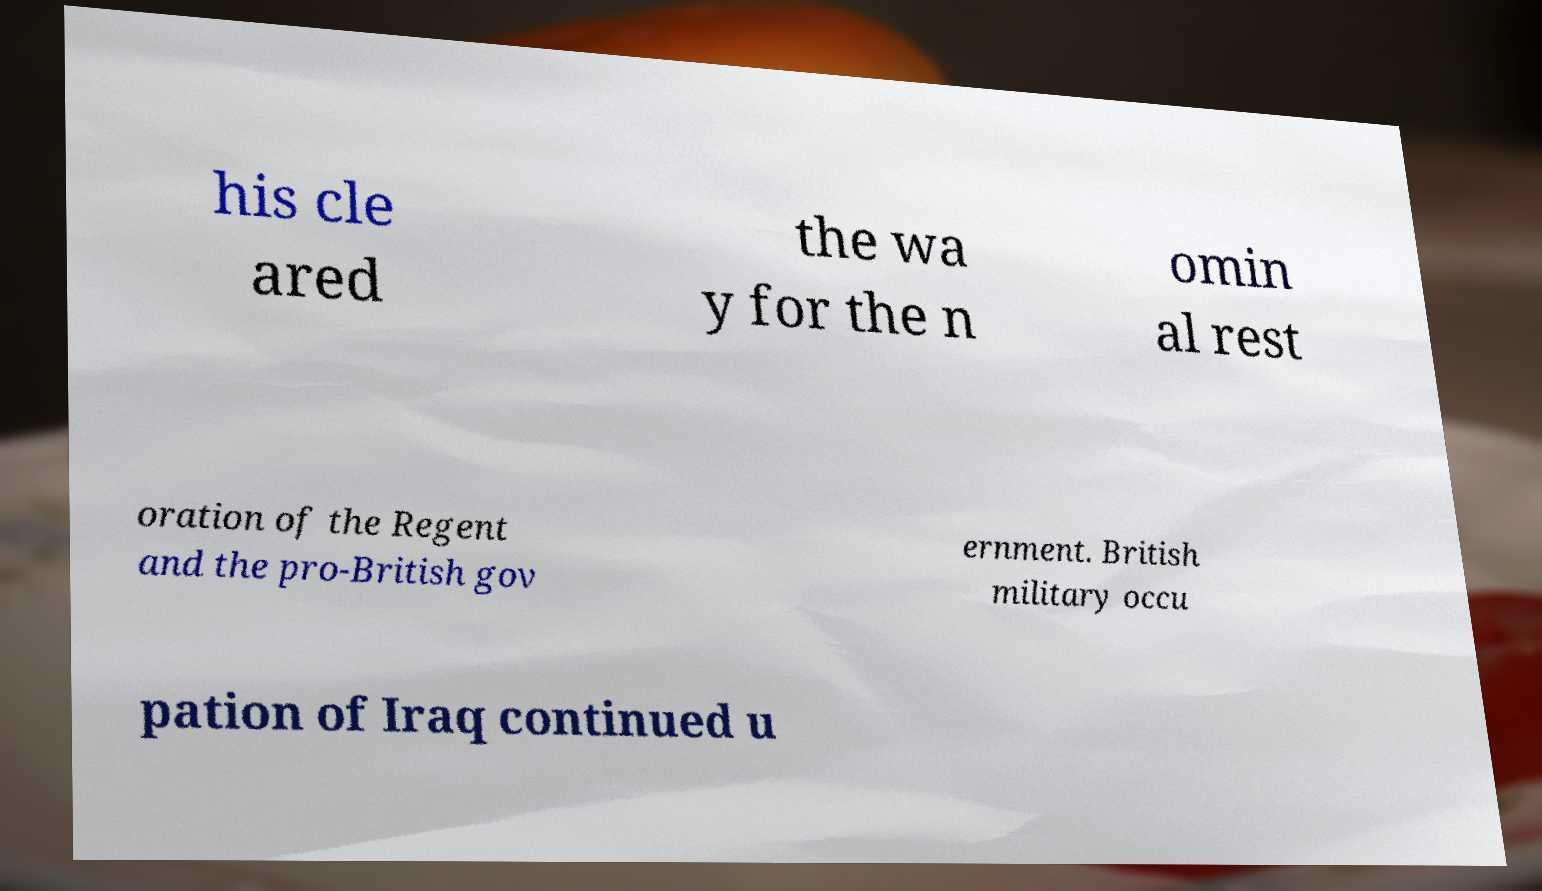I need the written content from this picture converted into text. Can you do that? his cle ared the wa y for the n omin al rest oration of the Regent and the pro-British gov ernment. British military occu pation of Iraq continued u 